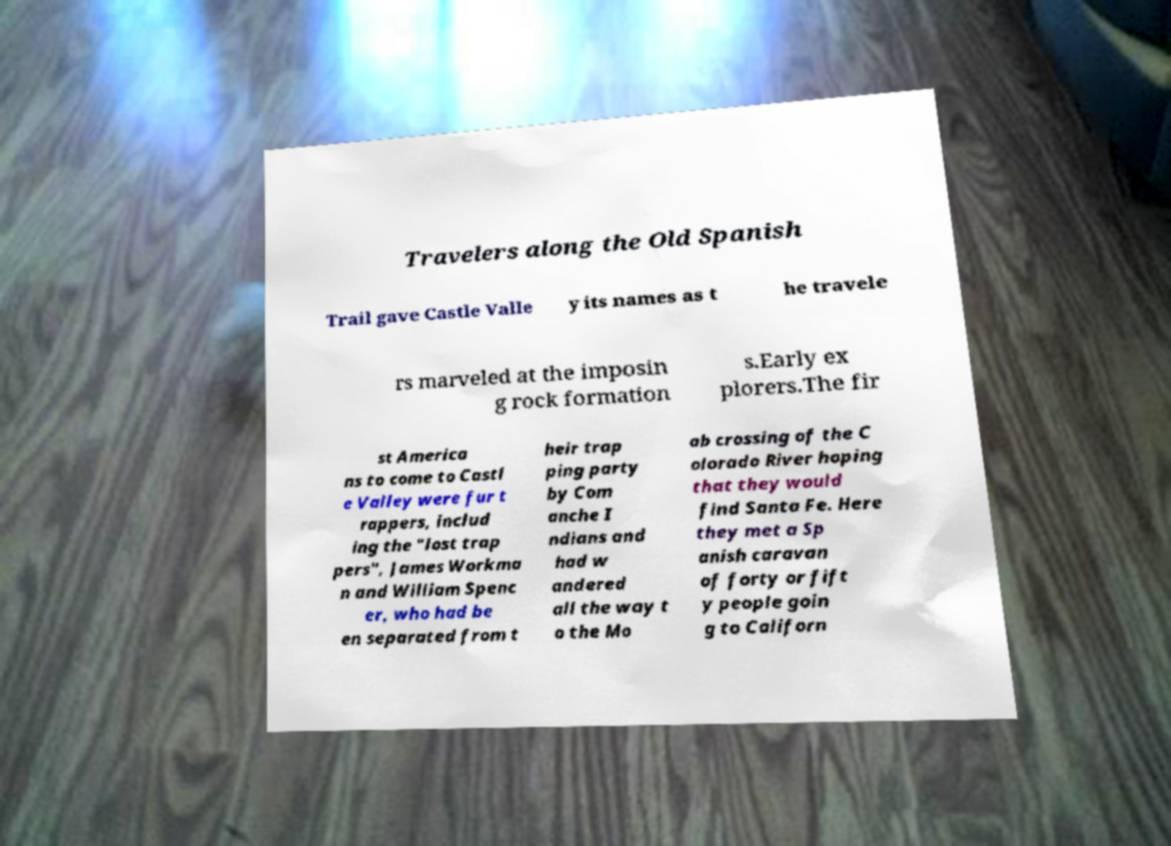Please identify and transcribe the text found in this image. Travelers along the Old Spanish Trail gave Castle Valle y its names as t he travele rs marveled at the imposin g rock formation s.Early ex plorers.The fir st America ns to come to Castl e Valley were fur t rappers, includ ing the "lost trap pers", James Workma n and William Spenc er, who had be en separated from t heir trap ping party by Com anche I ndians and had w andered all the way t o the Mo ab crossing of the C olorado River hoping that they would find Santa Fe. Here they met a Sp anish caravan of forty or fift y people goin g to Californ 